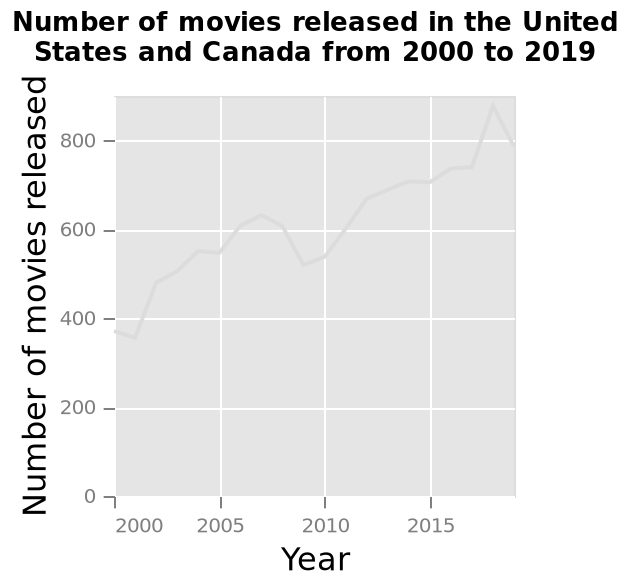<image>
How would you describe the relationship between the variables? The relationship between the variables is positive correlation. Offer a thorough analysis of the image. The graph shows positive correlation with the number of movies increasing. please describe the details of the chart Number of movies released in the United States and Canada from 2000 to 2019 is a line diagram. On the y-axis, Number of movies released is plotted. There is a linear scale of range 2000 to 2015 along the x-axis, labeled Year. What is the range of the x-axis? The x-axis has a linear scale ranging from 2000 to 2015. What variable is increasing on the graph? The number of movies is increasing. 